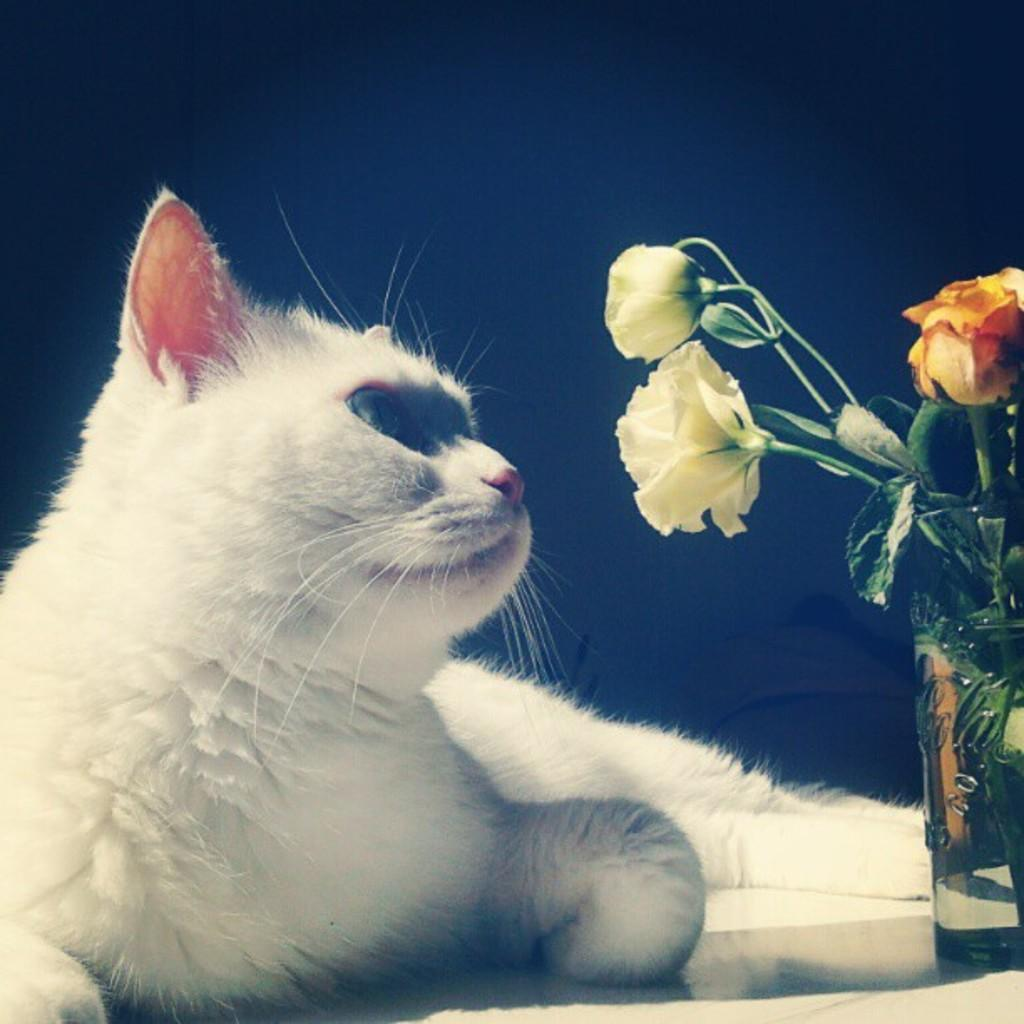What type of animal is in the image? There is a cat in the image. What is the cat doing in the image? The cat is lying on the floor. What else can be seen in the image besides the cat? There is a glass in the image. What is inside the glass? Rose flowers are present in the glass. How many girls are playing with the cat in the image? There are no girls present in the image; it only features a cat lying on the floor and a glass with rose flowers. Is there a carpenter working on a project in the image? There is no carpenter or any indication of a project being worked on in the image. 